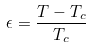Convert formula to latex. <formula><loc_0><loc_0><loc_500><loc_500>\epsilon = \frac { T - T _ { c } } { T _ { c } }</formula> 